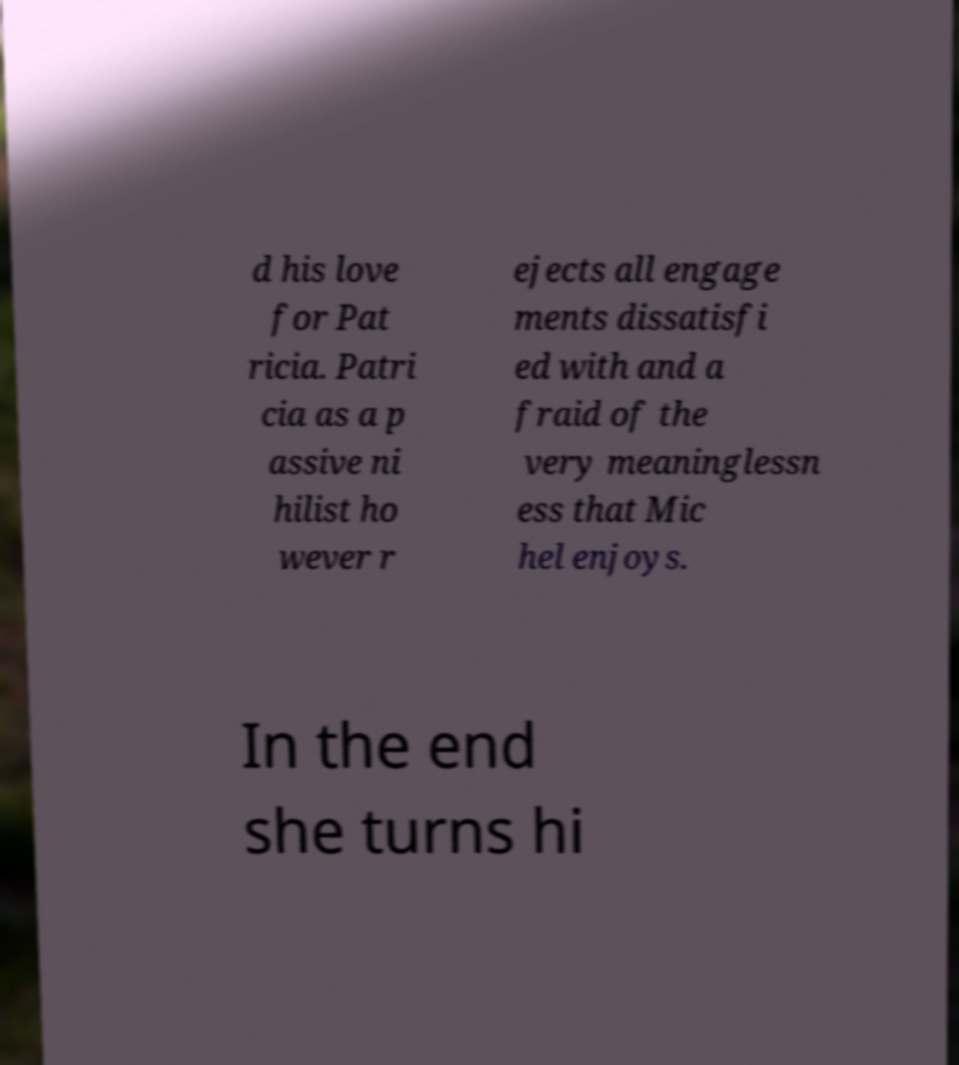Could you extract and type out the text from this image? d his love for Pat ricia. Patri cia as a p assive ni hilist ho wever r ejects all engage ments dissatisfi ed with and a fraid of the very meaninglessn ess that Mic hel enjoys. In the end she turns hi 